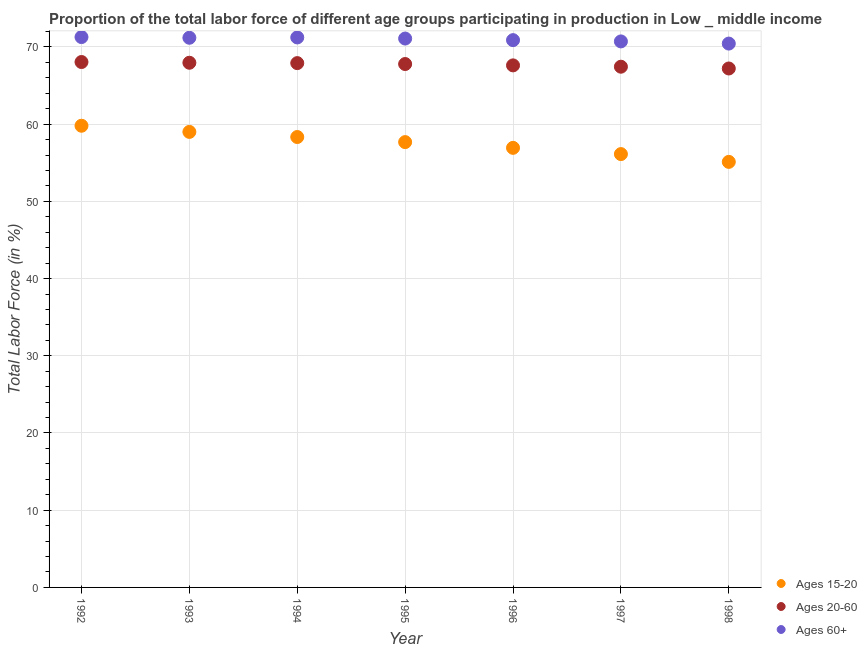How many different coloured dotlines are there?
Provide a succinct answer. 3. Is the number of dotlines equal to the number of legend labels?
Give a very brief answer. Yes. What is the percentage of labor force within the age group 15-20 in 1994?
Offer a terse response. 58.33. Across all years, what is the maximum percentage of labor force above age 60?
Your answer should be very brief. 71.28. Across all years, what is the minimum percentage of labor force within the age group 20-60?
Offer a terse response. 67.21. What is the total percentage of labor force within the age group 20-60 in the graph?
Ensure brevity in your answer.  473.94. What is the difference between the percentage of labor force within the age group 20-60 in 1992 and that in 1997?
Your response must be concise. 0.61. What is the difference between the percentage of labor force within the age group 15-20 in 1998 and the percentage of labor force above age 60 in 1995?
Keep it short and to the point. -15.97. What is the average percentage of labor force above age 60 per year?
Provide a short and direct response. 70.97. In the year 1998, what is the difference between the percentage of labor force within the age group 20-60 and percentage of labor force above age 60?
Your response must be concise. -3.23. In how many years, is the percentage of labor force within the age group 15-20 greater than 42 %?
Your answer should be compact. 7. What is the ratio of the percentage of labor force within the age group 20-60 in 1994 to that in 1997?
Your answer should be compact. 1.01. Is the percentage of labor force within the age group 15-20 in 1995 less than that in 1997?
Keep it short and to the point. No. Is the difference between the percentage of labor force within the age group 20-60 in 1994 and 1996 greater than the difference between the percentage of labor force within the age group 15-20 in 1994 and 1996?
Offer a terse response. No. What is the difference between the highest and the second highest percentage of labor force within the age group 15-20?
Provide a succinct answer. 0.8. What is the difference between the highest and the lowest percentage of labor force within the age group 20-60?
Provide a succinct answer. 0.84. In how many years, is the percentage of labor force within the age group 15-20 greater than the average percentage of labor force within the age group 15-20 taken over all years?
Give a very brief answer. 4. Is the sum of the percentage of labor force within the age group 15-20 in 1994 and 1998 greater than the maximum percentage of labor force above age 60 across all years?
Ensure brevity in your answer.  Yes. Is it the case that in every year, the sum of the percentage of labor force within the age group 15-20 and percentage of labor force within the age group 20-60 is greater than the percentage of labor force above age 60?
Provide a succinct answer. Yes. Does the percentage of labor force within the age group 15-20 monotonically increase over the years?
Offer a very short reply. No. Is the percentage of labor force above age 60 strictly greater than the percentage of labor force within the age group 15-20 over the years?
Offer a very short reply. Yes. Is the percentage of labor force within the age group 20-60 strictly less than the percentage of labor force within the age group 15-20 over the years?
Give a very brief answer. No. How many dotlines are there?
Keep it short and to the point. 3. What is the difference between two consecutive major ticks on the Y-axis?
Your response must be concise. 10. Does the graph contain any zero values?
Offer a very short reply. No. Does the graph contain grids?
Offer a terse response. Yes. How are the legend labels stacked?
Keep it short and to the point. Vertical. What is the title of the graph?
Provide a succinct answer. Proportion of the total labor force of different age groups participating in production in Low _ middle income. Does "Tertiary education" appear as one of the legend labels in the graph?
Keep it short and to the point. No. What is the label or title of the X-axis?
Make the answer very short. Year. What is the Total Labor Force (in %) of Ages 15-20 in 1992?
Keep it short and to the point. 59.79. What is the Total Labor Force (in %) of Ages 20-60 in 1992?
Provide a succinct answer. 68.05. What is the Total Labor Force (in %) in Ages 60+ in 1992?
Your answer should be compact. 71.28. What is the Total Labor Force (in %) in Ages 15-20 in 1993?
Provide a succinct answer. 59. What is the Total Labor Force (in %) in Ages 20-60 in 1993?
Make the answer very short. 67.95. What is the Total Labor Force (in %) in Ages 60+ in 1993?
Provide a short and direct response. 71.19. What is the Total Labor Force (in %) in Ages 15-20 in 1994?
Make the answer very short. 58.33. What is the Total Labor Force (in %) of Ages 20-60 in 1994?
Your answer should be compact. 67.9. What is the Total Labor Force (in %) of Ages 60+ in 1994?
Your answer should be compact. 71.23. What is the Total Labor Force (in %) of Ages 15-20 in 1995?
Offer a very short reply. 57.67. What is the Total Labor Force (in %) in Ages 20-60 in 1995?
Offer a terse response. 67.79. What is the Total Labor Force (in %) of Ages 60+ in 1995?
Give a very brief answer. 71.08. What is the Total Labor Force (in %) in Ages 15-20 in 1996?
Keep it short and to the point. 56.93. What is the Total Labor Force (in %) of Ages 20-60 in 1996?
Provide a succinct answer. 67.61. What is the Total Labor Force (in %) of Ages 60+ in 1996?
Your answer should be very brief. 70.88. What is the Total Labor Force (in %) in Ages 15-20 in 1997?
Provide a succinct answer. 56.12. What is the Total Labor Force (in %) in Ages 20-60 in 1997?
Your answer should be compact. 67.44. What is the Total Labor Force (in %) in Ages 60+ in 1997?
Provide a succinct answer. 70.71. What is the Total Labor Force (in %) of Ages 15-20 in 1998?
Offer a very short reply. 55.11. What is the Total Labor Force (in %) of Ages 20-60 in 1998?
Keep it short and to the point. 67.21. What is the Total Labor Force (in %) of Ages 60+ in 1998?
Ensure brevity in your answer.  70.43. Across all years, what is the maximum Total Labor Force (in %) in Ages 15-20?
Make the answer very short. 59.79. Across all years, what is the maximum Total Labor Force (in %) of Ages 20-60?
Ensure brevity in your answer.  68.05. Across all years, what is the maximum Total Labor Force (in %) of Ages 60+?
Offer a terse response. 71.28. Across all years, what is the minimum Total Labor Force (in %) in Ages 15-20?
Provide a succinct answer. 55.11. Across all years, what is the minimum Total Labor Force (in %) of Ages 20-60?
Offer a terse response. 67.21. Across all years, what is the minimum Total Labor Force (in %) in Ages 60+?
Offer a terse response. 70.43. What is the total Total Labor Force (in %) of Ages 15-20 in the graph?
Make the answer very short. 402.96. What is the total Total Labor Force (in %) in Ages 20-60 in the graph?
Your answer should be compact. 473.94. What is the total Total Labor Force (in %) in Ages 60+ in the graph?
Provide a succinct answer. 496.8. What is the difference between the Total Labor Force (in %) in Ages 15-20 in 1992 and that in 1993?
Ensure brevity in your answer.  0.8. What is the difference between the Total Labor Force (in %) of Ages 20-60 in 1992 and that in 1993?
Your answer should be very brief. 0.1. What is the difference between the Total Labor Force (in %) of Ages 60+ in 1992 and that in 1993?
Your answer should be very brief. 0.09. What is the difference between the Total Labor Force (in %) in Ages 15-20 in 1992 and that in 1994?
Provide a short and direct response. 1.46. What is the difference between the Total Labor Force (in %) of Ages 20-60 in 1992 and that in 1994?
Ensure brevity in your answer.  0.14. What is the difference between the Total Labor Force (in %) in Ages 60+ in 1992 and that in 1994?
Your answer should be very brief. 0.05. What is the difference between the Total Labor Force (in %) in Ages 15-20 in 1992 and that in 1995?
Keep it short and to the point. 2.12. What is the difference between the Total Labor Force (in %) of Ages 20-60 in 1992 and that in 1995?
Offer a terse response. 0.26. What is the difference between the Total Labor Force (in %) of Ages 60+ in 1992 and that in 1995?
Your answer should be compact. 0.19. What is the difference between the Total Labor Force (in %) in Ages 15-20 in 1992 and that in 1996?
Your answer should be compact. 2.86. What is the difference between the Total Labor Force (in %) of Ages 20-60 in 1992 and that in 1996?
Your answer should be very brief. 0.44. What is the difference between the Total Labor Force (in %) in Ages 60+ in 1992 and that in 1996?
Provide a succinct answer. 0.4. What is the difference between the Total Labor Force (in %) of Ages 15-20 in 1992 and that in 1997?
Make the answer very short. 3.67. What is the difference between the Total Labor Force (in %) in Ages 20-60 in 1992 and that in 1997?
Keep it short and to the point. 0.61. What is the difference between the Total Labor Force (in %) in Ages 60+ in 1992 and that in 1997?
Ensure brevity in your answer.  0.56. What is the difference between the Total Labor Force (in %) in Ages 15-20 in 1992 and that in 1998?
Your answer should be compact. 4.68. What is the difference between the Total Labor Force (in %) in Ages 20-60 in 1992 and that in 1998?
Keep it short and to the point. 0.84. What is the difference between the Total Labor Force (in %) of Ages 60+ in 1992 and that in 1998?
Your answer should be compact. 0.84. What is the difference between the Total Labor Force (in %) of Ages 15-20 in 1993 and that in 1994?
Your response must be concise. 0.66. What is the difference between the Total Labor Force (in %) of Ages 20-60 in 1993 and that in 1994?
Offer a very short reply. 0.05. What is the difference between the Total Labor Force (in %) of Ages 60+ in 1993 and that in 1994?
Make the answer very short. -0.04. What is the difference between the Total Labor Force (in %) in Ages 15-20 in 1993 and that in 1995?
Offer a terse response. 1.32. What is the difference between the Total Labor Force (in %) in Ages 20-60 in 1993 and that in 1995?
Your answer should be very brief. 0.17. What is the difference between the Total Labor Force (in %) of Ages 60+ in 1993 and that in 1995?
Your response must be concise. 0.1. What is the difference between the Total Labor Force (in %) of Ages 15-20 in 1993 and that in 1996?
Keep it short and to the point. 2.07. What is the difference between the Total Labor Force (in %) of Ages 20-60 in 1993 and that in 1996?
Your response must be concise. 0.34. What is the difference between the Total Labor Force (in %) in Ages 60+ in 1993 and that in 1996?
Offer a terse response. 0.31. What is the difference between the Total Labor Force (in %) in Ages 15-20 in 1993 and that in 1997?
Provide a succinct answer. 2.87. What is the difference between the Total Labor Force (in %) of Ages 20-60 in 1993 and that in 1997?
Make the answer very short. 0.51. What is the difference between the Total Labor Force (in %) of Ages 60+ in 1993 and that in 1997?
Your response must be concise. 0.47. What is the difference between the Total Labor Force (in %) of Ages 15-20 in 1993 and that in 1998?
Offer a very short reply. 3.88. What is the difference between the Total Labor Force (in %) in Ages 20-60 in 1993 and that in 1998?
Offer a very short reply. 0.74. What is the difference between the Total Labor Force (in %) of Ages 60+ in 1993 and that in 1998?
Provide a succinct answer. 0.75. What is the difference between the Total Labor Force (in %) in Ages 15-20 in 1994 and that in 1995?
Provide a succinct answer. 0.66. What is the difference between the Total Labor Force (in %) in Ages 20-60 in 1994 and that in 1995?
Make the answer very short. 0.12. What is the difference between the Total Labor Force (in %) in Ages 60+ in 1994 and that in 1995?
Provide a succinct answer. 0.14. What is the difference between the Total Labor Force (in %) of Ages 15-20 in 1994 and that in 1996?
Offer a very short reply. 1.4. What is the difference between the Total Labor Force (in %) in Ages 20-60 in 1994 and that in 1996?
Keep it short and to the point. 0.29. What is the difference between the Total Labor Force (in %) of Ages 60+ in 1994 and that in 1996?
Offer a terse response. 0.35. What is the difference between the Total Labor Force (in %) of Ages 15-20 in 1994 and that in 1997?
Your answer should be very brief. 2.21. What is the difference between the Total Labor Force (in %) of Ages 20-60 in 1994 and that in 1997?
Your answer should be compact. 0.47. What is the difference between the Total Labor Force (in %) of Ages 60+ in 1994 and that in 1997?
Offer a very short reply. 0.51. What is the difference between the Total Labor Force (in %) of Ages 15-20 in 1994 and that in 1998?
Provide a succinct answer. 3.22. What is the difference between the Total Labor Force (in %) of Ages 20-60 in 1994 and that in 1998?
Your response must be concise. 0.7. What is the difference between the Total Labor Force (in %) of Ages 60+ in 1994 and that in 1998?
Keep it short and to the point. 0.79. What is the difference between the Total Labor Force (in %) in Ages 15-20 in 1995 and that in 1996?
Offer a very short reply. 0.74. What is the difference between the Total Labor Force (in %) of Ages 20-60 in 1995 and that in 1996?
Make the answer very short. 0.18. What is the difference between the Total Labor Force (in %) in Ages 60+ in 1995 and that in 1996?
Your answer should be compact. 0.2. What is the difference between the Total Labor Force (in %) of Ages 15-20 in 1995 and that in 1997?
Offer a terse response. 1.55. What is the difference between the Total Labor Force (in %) of Ages 20-60 in 1995 and that in 1997?
Offer a terse response. 0.35. What is the difference between the Total Labor Force (in %) in Ages 60+ in 1995 and that in 1997?
Keep it short and to the point. 0.37. What is the difference between the Total Labor Force (in %) of Ages 15-20 in 1995 and that in 1998?
Give a very brief answer. 2.56. What is the difference between the Total Labor Force (in %) in Ages 20-60 in 1995 and that in 1998?
Provide a short and direct response. 0.58. What is the difference between the Total Labor Force (in %) of Ages 60+ in 1995 and that in 1998?
Keep it short and to the point. 0.65. What is the difference between the Total Labor Force (in %) in Ages 15-20 in 1996 and that in 1997?
Your response must be concise. 0.81. What is the difference between the Total Labor Force (in %) of Ages 20-60 in 1996 and that in 1997?
Provide a short and direct response. 0.17. What is the difference between the Total Labor Force (in %) of Ages 60+ in 1996 and that in 1997?
Give a very brief answer. 0.17. What is the difference between the Total Labor Force (in %) in Ages 15-20 in 1996 and that in 1998?
Provide a short and direct response. 1.82. What is the difference between the Total Labor Force (in %) of Ages 20-60 in 1996 and that in 1998?
Your answer should be compact. 0.4. What is the difference between the Total Labor Force (in %) in Ages 60+ in 1996 and that in 1998?
Make the answer very short. 0.45. What is the difference between the Total Labor Force (in %) in Ages 15-20 in 1997 and that in 1998?
Ensure brevity in your answer.  1.01. What is the difference between the Total Labor Force (in %) of Ages 20-60 in 1997 and that in 1998?
Your answer should be compact. 0.23. What is the difference between the Total Labor Force (in %) in Ages 60+ in 1997 and that in 1998?
Offer a terse response. 0.28. What is the difference between the Total Labor Force (in %) in Ages 15-20 in 1992 and the Total Labor Force (in %) in Ages 20-60 in 1993?
Provide a short and direct response. -8.16. What is the difference between the Total Labor Force (in %) of Ages 15-20 in 1992 and the Total Labor Force (in %) of Ages 60+ in 1993?
Offer a terse response. -11.4. What is the difference between the Total Labor Force (in %) in Ages 20-60 in 1992 and the Total Labor Force (in %) in Ages 60+ in 1993?
Give a very brief answer. -3.14. What is the difference between the Total Labor Force (in %) of Ages 15-20 in 1992 and the Total Labor Force (in %) of Ages 20-60 in 1994?
Your answer should be very brief. -8.11. What is the difference between the Total Labor Force (in %) of Ages 15-20 in 1992 and the Total Labor Force (in %) of Ages 60+ in 1994?
Make the answer very short. -11.44. What is the difference between the Total Labor Force (in %) in Ages 20-60 in 1992 and the Total Labor Force (in %) in Ages 60+ in 1994?
Offer a terse response. -3.18. What is the difference between the Total Labor Force (in %) of Ages 15-20 in 1992 and the Total Labor Force (in %) of Ages 20-60 in 1995?
Offer a terse response. -7.99. What is the difference between the Total Labor Force (in %) of Ages 15-20 in 1992 and the Total Labor Force (in %) of Ages 60+ in 1995?
Offer a terse response. -11.29. What is the difference between the Total Labor Force (in %) of Ages 20-60 in 1992 and the Total Labor Force (in %) of Ages 60+ in 1995?
Your answer should be very brief. -3.04. What is the difference between the Total Labor Force (in %) of Ages 15-20 in 1992 and the Total Labor Force (in %) of Ages 20-60 in 1996?
Offer a terse response. -7.82. What is the difference between the Total Labor Force (in %) of Ages 15-20 in 1992 and the Total Labor Force (in %) of Ages 60+ in 1996?
Make the answer very short. -11.09. What is the difference between the Total Labor Force (in %) of Ages 20-60 in 1992 and the Total Labor Force (in %) of Ages 60+ in 1996?
Your answer should be very brief. -2.83. What is the difference between the Total Labor Force (in %) of Ages 15-20 in 1992 and the Total Labor Force (in %) of Ages 20-60 in 1997?
Keep it short and to the point. -7.65. What is the difference between the Total Labor Force (in %) of Ages 15-20 in 1992 and the Total Labor Force (in %) of Ages 60+ in 1997?
Your answer should be very brief. -10.92. What is the difference between the Total Labor Force (in %) of Ages 20-60 in 1992 and the Total Labor Force (in %) of Ages 60+ in 1997?
Provide a succinct answer. -2.67. What is the difference between the Total Labor Force (in %) of Ages 15-20 in 1992 and the Total Labor Force (in %) of Ages 20-60 in 1998?
Ensure brevity in your answer.  -7.42. What is the difference between the Total Labor Force (in %) in Ages 15-20 in 1992 and the Total Labor Force (in %) in Ages 60+ in 1998?
Your answer should be compact. -10.64. What is the difference between the Total Labor Force (in %) in Ages 20-60 in 1992 and the Total Labor Force (in %) in Ages 60+ in 1998?
Offer a terse response. -2.39. What is the difference between the Total Labor Force (in %) in Ages 15-20 in 1993 and the Total Labor Force (in %) in Ages 20-60 in 1994?
Offer a very short reply. -8.91. What is the difference between the Total Labor Force (in %) in Ages 15-20 in 1993 and the Total Labor Force (in %) in Ages 60+ in 1994?
Give a very brief answer. -12.23. What is the difference between the Total Labor Force (in %) of Ages 20-60 in 1993 and the Total Labor Force (in %) of Ages 60+ in 1994?
Offer a terse response. -3.28. What is the difference between the Total Labor Force (in %) of Ages 15-20 in 1993 and the Total Labor Force (in %) of Ages 20-60 in 1995?
Provide a short and direct response. -8.79. What is the difference between the Total Labor Force (in %) of Ages 15-20 in 1993 and the Total Labor Force (in %) of Ages 60+ in 1995?
Your answer should be compact. -12.09. What is the difference between the Total Labor Force (in %) in Ages 20-60 in 1993 and the Total Labor Force (in %) in Ages 60+ in 1995?
Your response must be concise. -3.13. What is the difference between the Total Labor Force (in %) in Ages 15-20 in 1993 and the Total Labor Force (in %) in Ages 20-60 in 1996?
Your response must be concise. -8.61. What is the difference between the Total Labor Force (in %) of Ages 15-20 in 1993 and the Total Labor Force (in %) of Ages 60+ in 1996?
Give a very brief answer. -11.89. What is the difference between the Total Labor Force (in %) in Ages 20-60 in 1993 and the Total Labor Force (in %) in Ages 60+ in 1996?
Offer a terse response. -2.93. What is the difference between the Total Labor Force (in %) in Ages 15-20 in 1993 and the Total Labor Force (in %) in Ages 20-60 in 1997?
Provide a succinct answer. -8.44. What is the difference between the Total Labor Force (in %) of Ages 15-20 in 1993 and the Total Labor Force (in %) of Ages 60+ in 1997?
Provide a succinct answer. -11.72. What is the difference between the Total Labor Force (in %) in Ages 20-60 in 1993 and the Total Labor Force (in %) in Ages 60+ in 1997?
Provide a short and direct response. -2.76. What is the difference between the Total Labor Force (in %) in Ages 15-20 in 1993 and the Total Labor Force (in %) in Ages 20-60 in 1998?
Provide a short and direct response. -8.21. What is the difference between the Total Labor Force (in %) of Ages 15-20 in 1993 and the Total Labor Force (in %) of Ages 60+ in 1998?
Your answer should be compact. -11.44. What is the difference between the Total Labor Force (in %) in Ages 20-60 in 1993 and the Total Labor Force (in %) in Ages 60+ in 1998?
Your response must be concise. -2.48. What is the difference between the Total Labor Force (in %) in Ages 15-20 in 1994 and the Total Labor Force (in %) in Ages 20-60 in 1995?
Provide a short and direct response. -9.45. What is the difference between the Total Labor Force (in %) of Ages 15-20 in 1994 and the Total Labor Force (in %) of Ages 60+ in 1995?
Provide a succinct answer. -12.75. What is the difference between the Total Labor Force (in %) in Ages 20-60 in 1994 and the Total Labor Force (in %) in Ages 60+ in 1995?
Offer a very short reply. -3.18. What is the difference between the Total Labor Force (in %) in Ages 15-20 in 1994 and the Total Labor Force (in %) in Ages 20-60 in 1996?
Offer a terse response. -9.28. What is the difference between the Total Labor Force (in %) in Ages 15-20 in 1994 and the Total Labor Force (in %) in Ages 60+ in 1996?
Your answer should be compact. -12.55. What is the difference between the Total Labor Force (in %) of Ages 20-60 in 1994 and the Total Labor Force (in %) of Ages 60+ in 1996?
Your response must be concise. -2.98. What is the difference between the Total Labor Force (in %) of Ages 15-20 in 1994 and the Total Labor Force (in %) of Ages 20-60 in 1997?
Your answer should be very brief. -9.1. What is the difference between the Total Labor Force (in %) in Ages 15-20 in 1994 and the Total Labor Force (in %) in Ages 60+ in 1997?
Keep it short and to the point. -12.38. What is the difference between the Total Labor Force (in %) in Ages 20-60 in 1994 and the Total Labor Force (in %) in Ages 60+ in 1997?
Offer a terse response. -2.81. What is the difference between the Total Labor Force (in %) in Ages 15-20 in 1994 and the Total Labor Force (in %) in Ages 20-60 in 1998?
Offer a terse response. -8.87. What is the difference between the Total Labor Force (in %) of Ages 15-20 in 1994 and the Total Labor Force (in %) of Ages 60+ in 1998?
Offer a terse response. -12.1. What is the difference between the Total Labor Force (in %) in Ages 20-60 in 1994 and the Total Labor Force (in %) in Ages 60+ in 1998?
Your response must be concise. -2.53. What is the difference between the Total Labor Force (in %) of Ages 15-20 in 1995 and the Total Labor Force (in %) of Ages 20-60 in 1996?
Provide a succinct answer. -9.94. What is the difference between the Total Labor Force (in %) in Ages 15-20 in 1995 and the Total Labor Force (in %) in Ages 60+ in 1996?
Give a very brief answer. -13.21. What is the difference between the Total Labor Force (in %) in Ages 20-60 in 1995 and the Total Labor Force (in %) in Ages 60+ in 1996?
Ensure brevity in your answer.  -3.1. What is the difference between the Total Labor Force (in %) in Ages 15-20 in 1995 and the Total Labor Force (in %) in Ages 20-60 in 1997?
Provide a succinct answer. -9.76. What is the difference between the Total Labor Force (in %) of Ages 15-20 in 1995 and the Total Labor Force (in %) of Ages 60+ in 1997?
Offer a terse response. -13.04. What is the difference between the Total Labor Force (in %) of Ages 20-60 in 1995 and the Total Labor Force (in %) of Ages 60+ in 1997?
Your response must be concise. -2.93. What is the difference between the Total Labor Force (in %) in Ages 15-20 in 1995 and the Total Labor Force (in %) in Ages 20-60 in 1998?
Offer a terse response. -9.53. What is the difference between the Total Labor Force (in %) in Ages 15-20 in 1995 and the Total Labor Force (in %) in Ages 60+ in 1998?
Provide a short and direct response. -12.76. What is the difference between the Total Labor Force (in %) in Ages 20-60 in 1995 and the Total Labor Force (in %) in Ages 60+ in 1998?
Give a very brief answer. -2.65. What is the difference between the Total Labor Force (in %) of Ages 15-20 in 1996 and the Total Labor Force (in %) of Ages 20-60 in 1997?
Keep it short and to the point. -10.51. What is the difference between the Total Labor Force (in %) of Ages 15-20 in 1996 and the Total Labor Force (in %) of Ages 60+ in 1997?
Provide a succinct answer. -13.78. What is the difference between the Total Labor Force (in %) of Ages 20-60 in 1996 and the Total Labor Force (in %) of Ages 60+ in 1997?
Offer a very short reply. -3.1. What is the difference between the Total Labor Force (in %) in Ages 15-20 in 1996 and the Total Labor Force (in %) in Ages 20-60 in 1998?
Your answer should be very brief. -10.28. What is the difference between the Total Labor Force (in %) of Ages 15-20 in 1996 and the Total Labor Force (in %) of Ages 60+ in 1998?
Make the answer very short. -13.5. What is the difference between the Total Labor Force (in %) of Ages 20-60 in 1996 and the Total Labor Force (in %) of Ages 60+ in 1998?
Give a very brief answer. -2.82. What is the difference between the Total Labor Force (in %) of Ages 15-20 in 1997 and the Total Labor Force (in %) of Ages 20-60 in 1998?
Your answer should be very brief. -11.09. What is the difference between the Total Labor Force (in %) in Ages 15-20 in 1997 and the Total Labor Force (in %) in Ages 60+ in 1998?
Offer a very short reply. -14.31. What is the difference between the Total Labor Force (in %) of Ages 20-60 in 1997 and the Total Labor Force (in %) of Ages 60+ in 1998?
Your response must be concise. -3. What is the average Total Labor Force (in %) in Ages 15-20 per year?
Provide a short and direct response. 57.57. What is the average Total Labor Force (in %) in Ages 20-60 per year?
Make the answer very short. 67.71. What is the average Total Labor Force (in %) in Ages 60+ per year?
Offer a terse response. 70.97. In the year 1992, what is the difference between the Total Labor Force (in %) in Ages 15-20 and Total Labor Force (in %) in Ages 20-60?
Keep it short and to the point. -8.25. In the year 1992, what is the difference between the Total Labor Force (in %) of Ages 15-20 and Total Labor Force (in %) of Ages 60+?
Offer a terse response. -11.49. In the year 1992, what is the difference between the Total Labor Force (in %) in Ages 20-60 and Total Labor Force (in %) in Ages 60+?
Provide a short and direct response. -3.23. In the year 1993, what is the difference between the Total Labor Force (in %) in Ages 15-20 and Total Labor Force (in %) in Ages 20-60?
Ensure brevity in your answer.  -8.96. In the year 1993, what is the difference between the Total Labor Force (in %) in Ages 15-20 and Total Labor Force (in %) in Ages 60+?
Offer a terse response. -12.19. In the year 1993, what is the difference between the Total Labor Force (in %) in Ages 20-60 and Total Labor Force (in %) in Ages 60+?
Keep it short and to the point. -3.24. In the year 1994, what is the difference between the Total Labor Force (in %) of Ages 15-20 and Total Labor Force (in %) of Ages 20-60?
Your answer should be very brief. -9.57. In the year 1994, what is the difference between the Total Labor Force (in %) in Ages 15-20 and Total Labor Force (in %) in Ages 60+?
Provide a short and direct response. -12.9. In the year 1994, what is the difference between the Total Labor Force (in %) of Ages 20-60 and Total Labor Force (in %) of Ages 60+?
Provide a short and direct response. -3.32. In the year 1995, what is the difference between the Total Labor Force (in %) in Ages 15-20 and Total Labor Force (in %) in Ages 20-60?
Keep it short and to the point. -10.11. In the year 1995, what is the difference between the Total Labor Force (in %) in Ages 15-20 and Total Labor Force (in %) in Ages 60+?
Provide a succinct answer. -13.41. In the year 1995, what is the difference between the Total Labor Force (in %) in Ages 20-60 and Total Labor Force (in %) in Ages 60+?
Make the answer very short. -3.3. In the year 1996, what is the difference between the Total Labor Force (in %) in Ages 15-20 and Total Labor Force (in %) in Ages 20-60?
Provide a short and direct response. -10.68. In the year 1996, what is the difference between the Total Labor Force (in %) in Ages 15-20 and Total Labor Force (in %) in Ages 60+?
Provide a succinct answer. -13.95. In the year 1996, what is the difference between the Total Labor Force (in %) of Ages 20-60 and Total Labor Force (in %) of Ages 60+?
Offer a terse response. -3.27. In the year 1997, what is the difference between the Total Labor Force (in %) of Ages 15-20 and Total Labor Force (in %) of Ages 20-60?
Give a very brief answer. -11.32. In the year 1997, what is the difference between the Total Labor Force (in %) in Ages 15-20 and Total Labor Force (in %) in Ages 60+?
Your answer should be compact. -14.59. In the year 1997, what is the difference between the Total Labor Force (in %) in Ages 20-60 and Total Labor Force (in %) in Ages 60+?
Your answer should be compact. -3.28. In the year 1998, what is the difference between the Total Labor Force (in %) of Ages 15-20 and Total Labor Force (in %) of Ages 20-60?
Keep it short and to the point. -12.09. In the year 1998, what is the difference between the Total Labor Force (in %) of Ages 15-20 and Total Labor Force (in %) of Ages 60+?
Ensure brevity in your answer.  -15.32. In the year 1998, what is the difference between the Total Labor Force (in %) of Ages 20-60 and Total Labor Force (in %) of Ages 60+?
Your answer should be compact. -3.23. What is the ratio of the Total Labor Force (in %) of Ages 15-20 in 1992 to that in 1993?
Your answer should be very brief. 1.01. What is the ratio of the Total Labor Force (in %) of Ages 20-60 in 1992 to that in 1993?
Keep it short and to the point. 1. What is the ratio of the Total Labor Force (in %) of Ages 15-20 in 1992 to that in 1994?
Keep it short and to the point. 1.02. What is the ratio of the Total Labor Force (in %) in Ages 20-60 in 1992 to that in 1994?
Your response must be concise. 1. What is the ratio of the Total Labor Force (in %) of Ages 15-20 in 1992 to that in 1995?
Your answer should be compact. 1.04. What is the ratio of the Total Labor Force (in %) of Ages 20-60 in 1992 to that in 1995?
Your answer should be compact. 1. What is the ratio of the Total Labor Force (in %) of Ages 60+ in 1992 to that in 1995?
Ensure brevity in your answer.  1. What is the ratio of the Total Labor Force (in %) in Ages 15-20 in 1992 to that in 1996?
Your response must be concise. 1.05. What is the ratio of the Total Labor Force (in %) in Ages 20-60 in 1992 to that in 1996?
Provide a succinct answer. 1.01. What is the ratio of the Total Labor Force (in %) in Ages 60+ in 1992 to that in 1996?
Your answer should be very brief. 1.01. What is the ratio of the Total Labor Force (in %) of Ages 15-20 in 1992 to that in 1997?
Your answer should be compact. 1.07. What is the ratio of the Total Labor Force (in %) of Ages 20-60 in 1992 to that in 1997?
Ensure brevity in your answer.  1.01. What is the ratio of the Total Labor Force (in %) in Ages 60+ in 1992 to that in 1997?
Give a very brief answer. 1.01. What is the ratio of the Total Labor Force (in %) in Ages 15-20 in 1992 to that in 1998?
Your answer should be very brief. 1.08. What is the ratio of the Total Labor Force (in %) in Ages 20-60 in 1992 to that in 1998?
Keep it short and to the point. 1.01. What is the ratio of the Total Labor Force (in %) of Ages 60+ in 1992 to that in 1998?
Provide a succinct answer. 1.01. What is the ratio of the Total Labor Force (in %) in Ages 15-20 in 1993 to that in 1994?
Offer a very short reply. 1.01. What is the ratio of the Total Labor Force (in %) of Ages 15-20 in 1993 to that in 1995?
Make the answer very short. 1.02. What is the ratio of the Total Labor Force (in %) in Ages 20-60 in 1993 to that in 1995?
Keep it short and to the point. 1. What is the ratio of the Total Labor Force (in %) in Ages 60+ in 1993 to that in 1995?
Provide a short and direct response. 1. What is the ratio of the Total Labor Force (in %) of Ages 15-20 in 1993 to that in 1996?
Make the answer very short. 1.04. What is the ratio of the Total Labor Force (in %) of Ages 60+ in 1993 to that in 1996?
Make the answer very short. 1. What is the ratio of the Total Labor Force (in %) in Ages 15-20 in 1993 to that in 1997?
Provide a short and direct response. 1.05. What is the ratio of the Total Labor Force (in %) in Ages 20-60 in 1993 to that in 1997?
Keep it short and to the point. 1.01. What is the ratio of the Total Labor Force (in %) in Ages 15-20 in 1993 to that in 1998?
Provide a short and direct response. 1.07. What is the ratio of the Total Labor Force (in %) in Ages 20-60 in 1993 to that in 1998?
Offer a very short reply. 1.01. What is the ratio of the Total Labor Force (in %) in Ages 60+ in 1993 to that in 1998?
Keep it short and to the point. 1.01. What is the ratio of the Total Labor Force (in %) of Ages 15-20 in 1994 to that in 1995?
Ensure brevity in your answer.  1.01. What is the ratio of the Total Labor Force (in %) in Ages 15-20 in 1994 to that in 1996?
Offer a terse response. 1.02. What is the ratio of the Total Labor Force (in %) in Ages 20-60 in 1994 to that in 1996?
Provide a short and direct response. 1. What is the ratio of the Total Labor Force (in %) in Ages 15-20 in 1994 to that in 1997?
Provide a short and direct response. 1.04. What is the ratio of the Total Labor Force (in %) of Ages 60+ in 1994 to that in 1997?
Offer a very short reply. 1.01. What is the ratio of the Total Labor Force (in %) of Ages 15-20 in 1994 to that in 1998?
Ensure brevity in your answer.  1.06. What is the ratio of the Total Labor Force (in %) in Ages 20-60 in 1994 to that in 1998?
Provide a succinct answer. 1.01. What is the ratio of the Total Labor Force (in %) in Ages 60+ in 1994 to that in 1998?
Your response must be concise. 1.01. What is the ratio of the Total Labor Force (in %) of Ages 15-20 in 1995 to that in 1996?
Your answer should be very brief. 1.01. What is the ratio of the Total Labor Force (in %) in Ages 20-60 in 1995 to that in 1996?
Offer a very short reply. 1. What is the ratio of the Total Labor Force (in %) of Ages 15-20 in 1995 to that in 1997?
Keep it short and to the point. 1.03. What is the ratio of the Total Labor Force (in %) of Ages 20-60 in 1995 to that in 1997?
Offer a terse response. 1.01. What is the ratio of the Total Labor Force (in %) of Ages 60+ in 1995 to that in 1997?
Keep it short and to the point. 1.01. What is the ratio of the Total Labor Force (in %) of Ages 15-20 in 1995 to that in 1998?
Your answer should be compact. 1.05. What is the ratio of the Total Labor Force (in %) in Ages 20-60 in 1995 to that in 1998?
Keep it short and to the point. 1.01. What is the ratio of the Total Labor Force (in %) of Ages 60+ in 1995 to that in 1998?
Ensure brevity in your answer.  1.01. What is the ratio of the Total Labor Force (in %) of Ages 15-20 in 1996 to that in 1997?
Make the answer very short. 1.01. What is the ratio of the Total Labor Force (in %) in Ages 15-20 in 1996 to that in 1998?
Offer a terse response. 1.03. What is the ratio of the Total Labor Force (in %) of Ages 60+ in 1996 to that in 1998?
Ensure brevity in your answer.  1.01. What is the ratio of the Total Labor Force (in %) in Ages 15-20 in 1997 to that in 1998?
Offer a terse response. 1.02. What is the ratio of the Total Labor Force (in %) of Ages 20-60 in 1997 to that in 1998?
Provide a short and direct response. 1. What is the difference between the highest and the second highest Total Labor Force (in %) in Ages 15-20?
Offer a very short reply. 0.8. What is the difference between the highest and the second highest Total Labor Force (in %) of Ages 20-60?
Make the answer very short. 0.1. What is the difference between the highest and the second highest Total Labor Force (in %) in Ages 60+?
Provide a short and direct response. 0.05. What is the difference between the highest and the lowest Total Labor Force (in %) in Ages 15-20?
Provide a succinct answer. 4.68. What is the difference between the highest and the lowest Total Labor Force (in %) in Ages 20-60?
Keep it short and to the point. 0.84. What is the difference between the highest and the lowest Total Labor Force (in %) in Ages 60+?
Give a very brief answer. 0.84. 